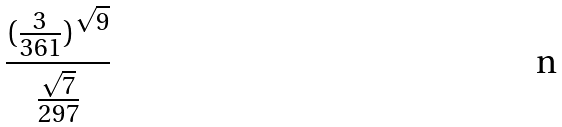Convert formula to latex. <formula><loc_0><loc_0><loc_500><loc_500>\frac { ( \frac { 3 } { 3 6 1 } ) ^ { \sqrt { 9 } } } { \frac { \sqrt { 7 } } { 2 9 7 } }</formula> 